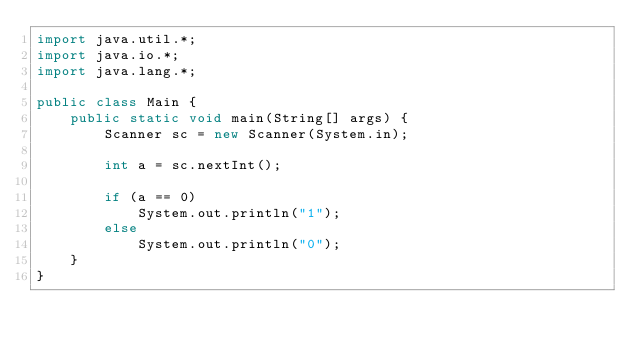Convert code to text. <code><loc_0><loc_0><loc_500><loc_500><_Java_>import java.util.*;
import java.io.*;
import java.lang.*;

public class Main {
    public static void main(String[] args) {
        Scanner sc = new Scanner(System.in);

        int a = sc.nextInt();
        
        if (a == 0)
            System.out.println("1");
        else
            System.out.println("0");
    }
}</code> 